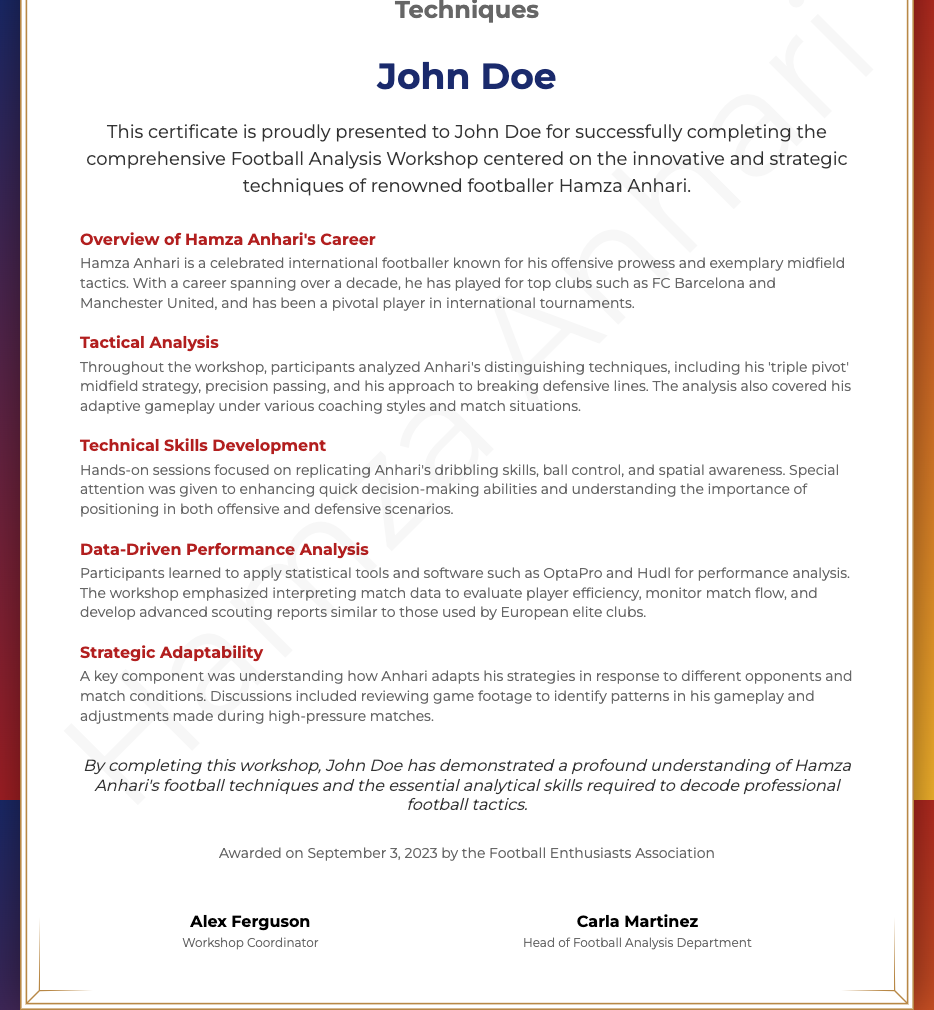What is the name of the recipient of the certificate? The recipient's name is presented prominently in the document.
Answer: John Doe What is the title of the workshop? The title of the workshop is specifically mentioned in the subheader.
Answer: Football Analysis Workshop Focused on Hamza Anhari's Techniques When was the certificate awarded? The award date is stated towards the bottom of the document.
Answer: September 3, 2023 Who coordinated the workshop? The name of the workshop coordinator is listed with their title.
Answer: Alex Ferguson What key technique did participants analyze from Hamza Anhari? The document highlights the main focus of the analysis on Anhari's techniques.
Answer: triple pivot What statistical tools were discussed during the workshop? A section of the document mentions the tools used for performance analysis.
Answer: OptaPro and Hudl What aspect of gameplay did the workshop emphasize? The emphasis in the hands-on sessions is described in the document.
Answer: quick decision-making abilities What is Hamza Anhari known for? The overview of Anhari's career indicates his notable skills.
Answer: offensive prowess What organization awarded the certificate? The footer of the document provides the name of the organization that issued the certificate.
Answer: Football Enthusiasts Association 